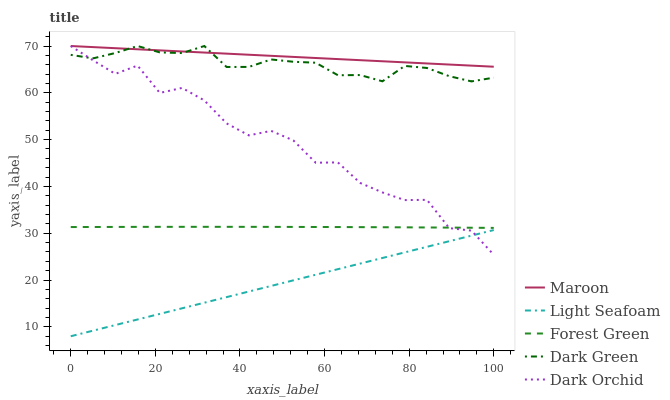Does Light Seafoam have the minimum area under the curve?
Answer yes or no. Yes. Does Maroon have the maximum area under the curve?
Answer yes or no. Yes. Does Dark Orchid have the minimum area under the curve?
Answer yes or no. No. Does Dark Orchid have the maximum area under the curve?
Answer yes or no. No. Is Light Seafoam the smoothest?
Answer yes or no. Yes. Is Dark Orchid the roughest?
Answer yes or no. Yes. Is Dark Orchid the smoothest?
Answer yes or no. No. Is Light Seafoam the roughest?
Answer yes or no. No. Does Light Seafoam have the lowest value?
Answer yes or no. Yes. Does Dark Orchid have the lowest value?
Answer yes or no. No. Does Dark Green have the highest value?
Answer yes or no. Yes. Does Light Seafoam have the highest value?
Answer yes or no. No. Is Forest Green less than Maroon?
Answer yes or no. Yes. Is Forest Green greater than Light Seafoam?
Answer yes or no. Yes. Does Dark Orchid intersect Dark Green?
Answer yes or no. Yes. Is Dark Orchid less than Dark Green?
Answer yes or no. No. Is Dark Orchid greater than Dark Green?
Answer yes or no. No. Does Forest Green intersect Maroon?
Answer yes or no. No. 